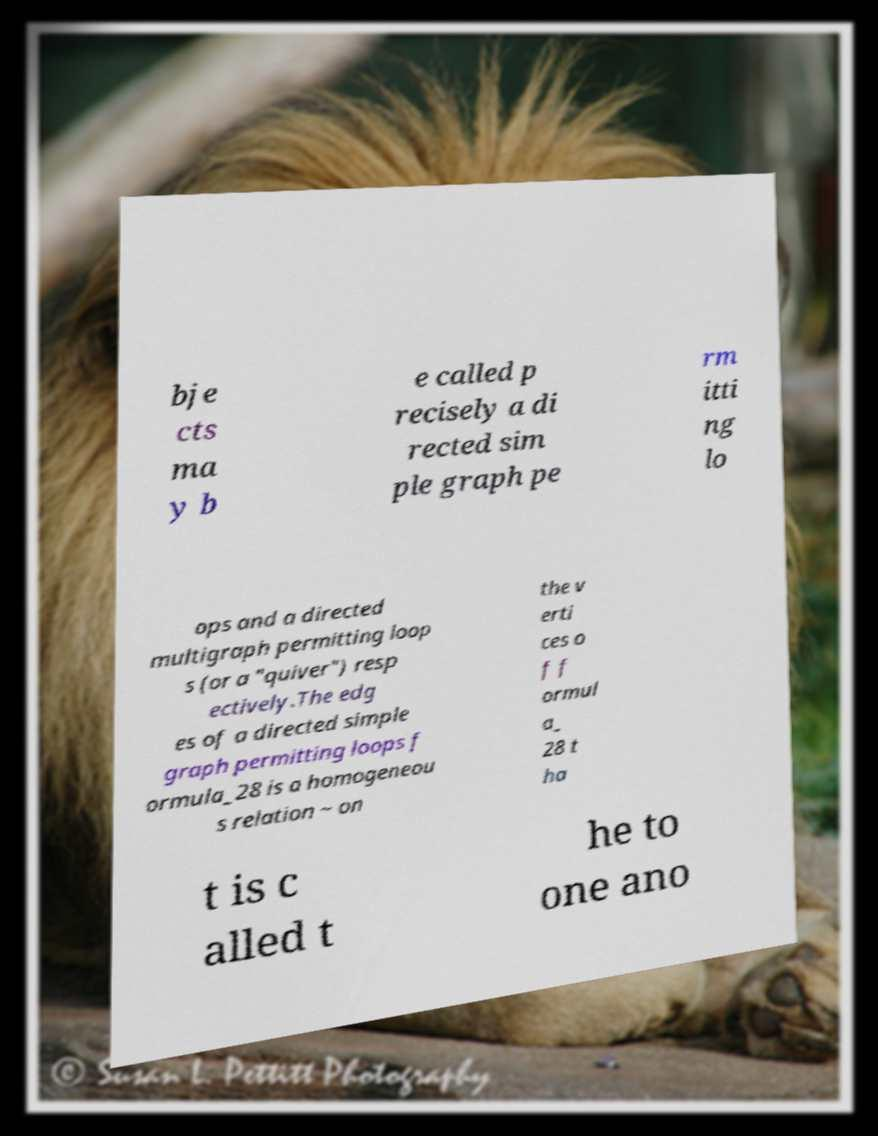Could you extract and type out the text from this image? bje cts ma y b e called p recisely a di rected sim ple graph pe rm itti ng lo ops and a directed multigraph permitting loop s (or a "quiver") resp ectively.The edg es of a directed simple graph permitting loops f ormula_28 is a homogeneou s relation ~ on the v erti ces o f f ormul a_ 28 t ha t is c alled t he to one ano 